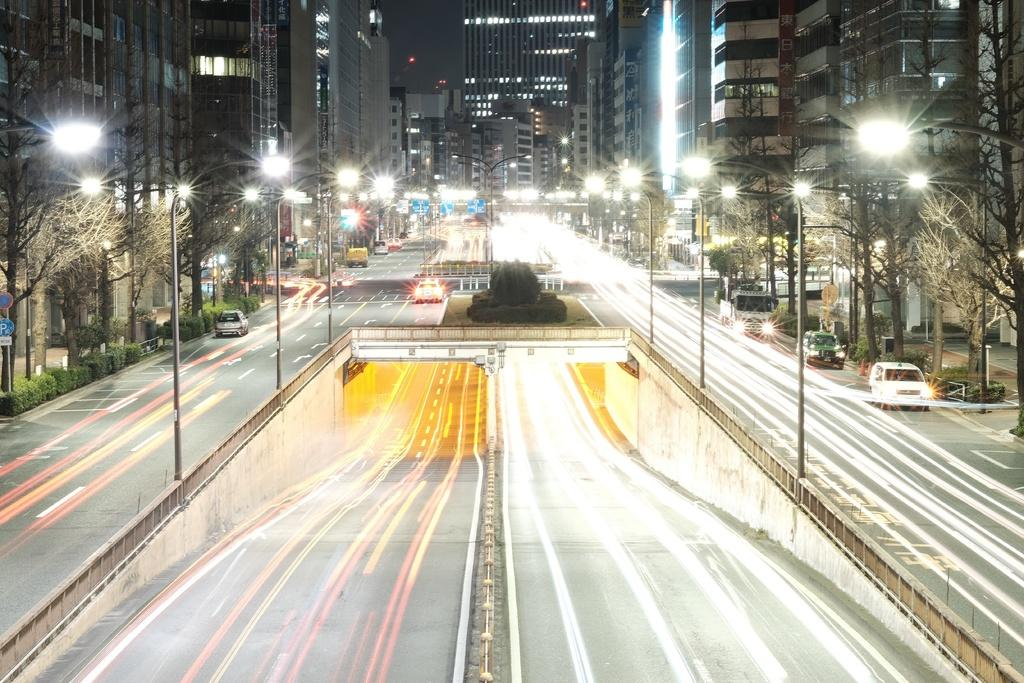What type of structures can be seen in the image? There are buildings with windows in the image. What are the light sources visible in the image? There are light poles in the image. What type of vegetation is present in the image? There are trees in the image. What type of transportation can be seen in the image? There are vehicles on the road in the image. How many frogs are sitting on the light poles in the image? There are no frogs present in the image; it features buildings, light poles, trees, and vehicles. What type of flame can be seen coming from the vehicles in the image? There is no flame visible in the image; the vehicles are not on fire. 